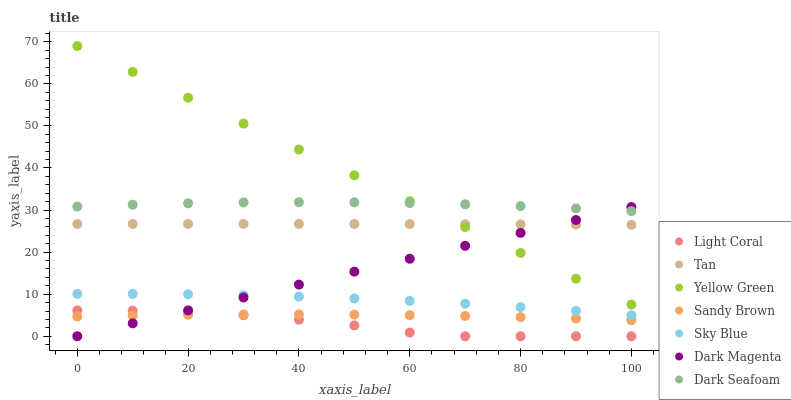Does Light Coral have the minimum area under the curve?
Answer yes or no. Yes. Does Yellow Green have the maximum area under the curve?
Answer yes or no. Yes. Does Dark Seafoam have the minimum area under the curve?
Answer yes or no. No. Does Dark Seafoam have the maximum area under the curve?
Answer yes or no. No. Is Dark Magenta the smoothest?
Answer yes or no. Yes. Is Light Coral the roughest?
Answer yes or no. Yes. Is Dark Seafoam the smoothest?
Answer yes or no. No. Is Dark Seafoam the roughest?
Answer yes or no. No. Does Light Coral have the lowest value?
Answer yes or no. Yes. Does Dark Seafoam have the lowest value?
Answer yes or no. No. Does Yellow Green have the highest value?
Answer yes or no. Yes. Does Light Coral have the highest value?
Answer yes or no. No. Is Light Coral less than Dark Seafoam?
Answer yes or no. Yes. Is Sky Blue greater than Sandy Brown?
Answer yes or no. Yes. Does Yellow Green intersect Dark Seafoam?
Answer yes or no. Yes. Is Yellow Green less than Dark Seafoam?
Answer yes or no. No. Is Yellow Green greater than Dark Seafoam?
Answer yes or no. No. Does Light Coral intersect Dark Seafoam?
Answer yes or no. No. 